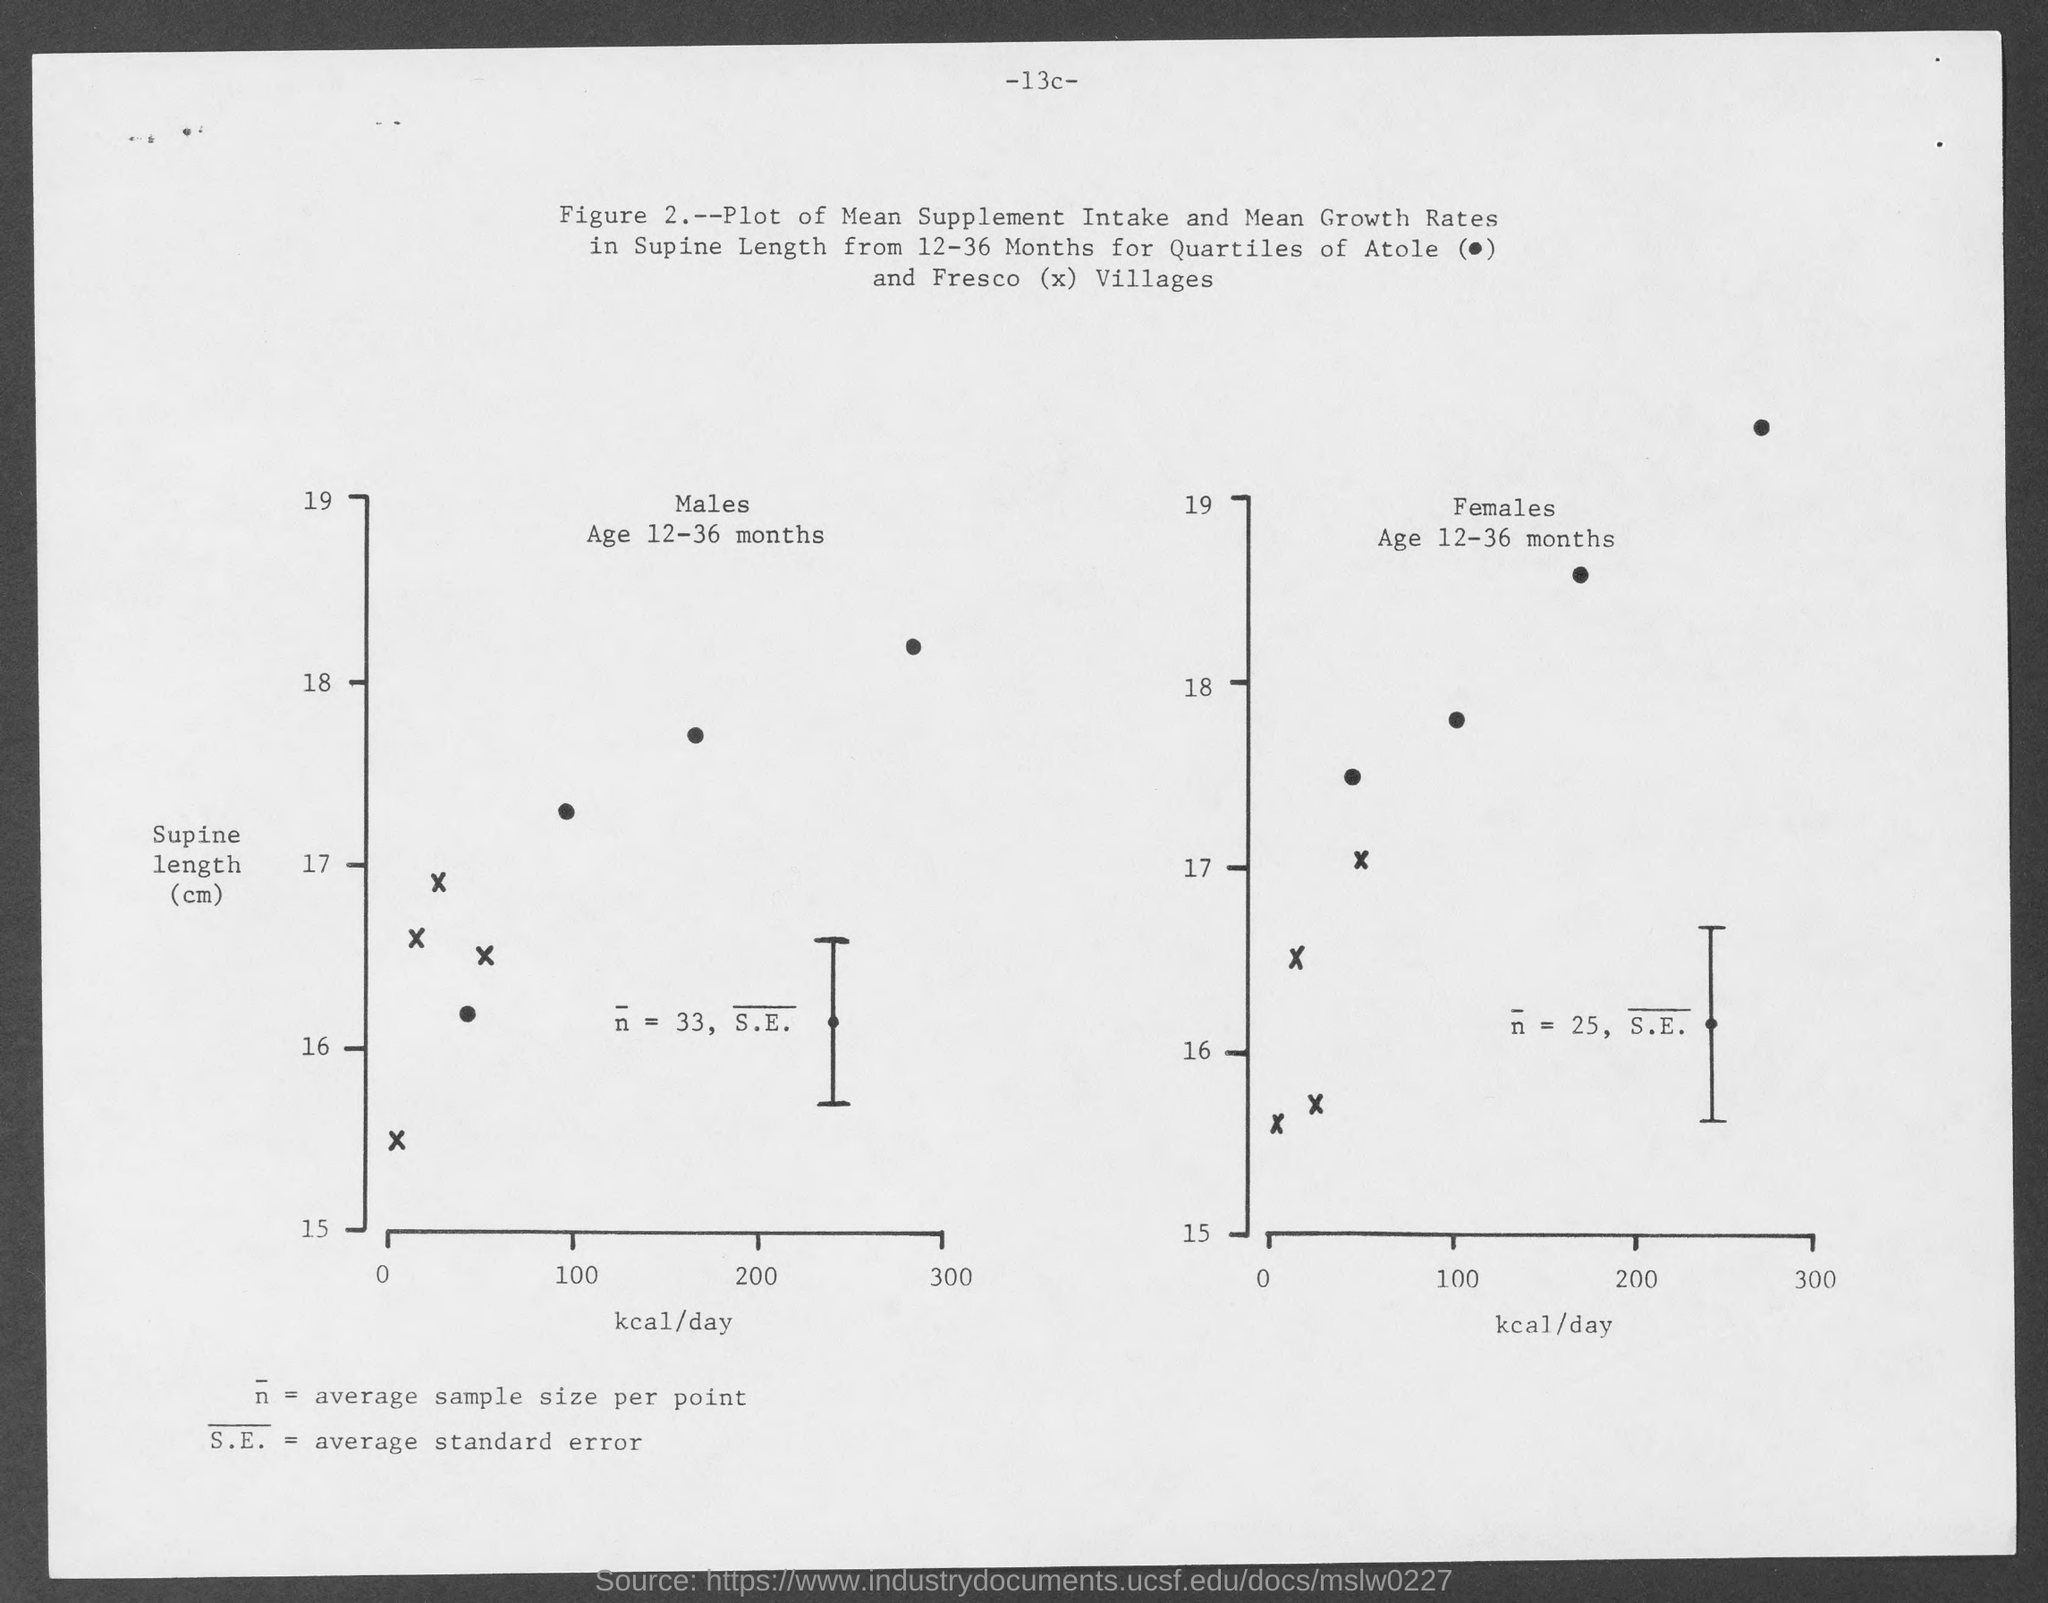Highlight a few significant elements in this photo. The suprarenal length is shown on the Y-axis of the graph, and the value is in centimeters. The maximum value of supine length (in centimeters) taken on the y-axis is 19. The value on the x-axis of the graph represents the number of kilocalories per day. The maximum amount of calories taken in per day for X is 300. 